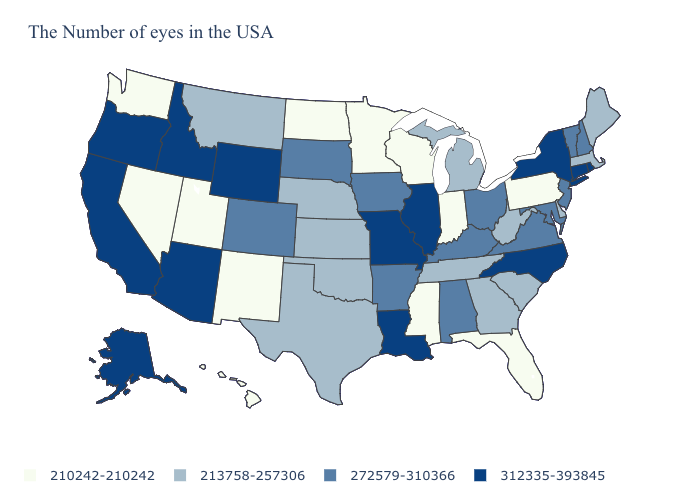Does Arizona have the lowest value in the West?
Concise answer only. No. Name the states that have a value in the range 210242-210242?
Short answer required. Pennsylvania, Florida, Indiana, Wisconsin, Mississippi, Minnesota, North Dakota, New Mexico, Utah, Nevada, Washington, Hawaii. Does Delaware have the same value as Georgia?
Be succinct. Yes. What is the value of New Jersey?
Keep it brief. 272579-310366. Which states hav the highest value in the South?
Quick response, please. North Carolina, Louisiana. What is the value of Arkansas?
Write a very short answer. 272579-310366. What is the highest value in the USA?
Answer briefly. 312335-393845. What is the lowest value in the USA?
Give a very brief answer. 210242-210242. Name the states that have a value in the range 210242-210242?
Give a very brief answer. Pennsylvania, Florida, Indiana, Wisconsin, Mississippi, Minnesota, North Dakota, New Mexico, Utah, Nevada, Washington, Hawaii. Does California have the highest value in the USA?
Concise answer only. Yes. Does Wyoming have a higher value than Washington?
Short answer required. Yes. Among the states that border Idaho , which have the highest value?
Short answer required. Wyoming, Oregon. What is the lowest value in the Northeast?
Answer briefly. 210242-210242. Does Wisconsin have the lowest value in the USA?
Concise answer only. Yes. Does the map have missing data?
Quick response, please. No. 